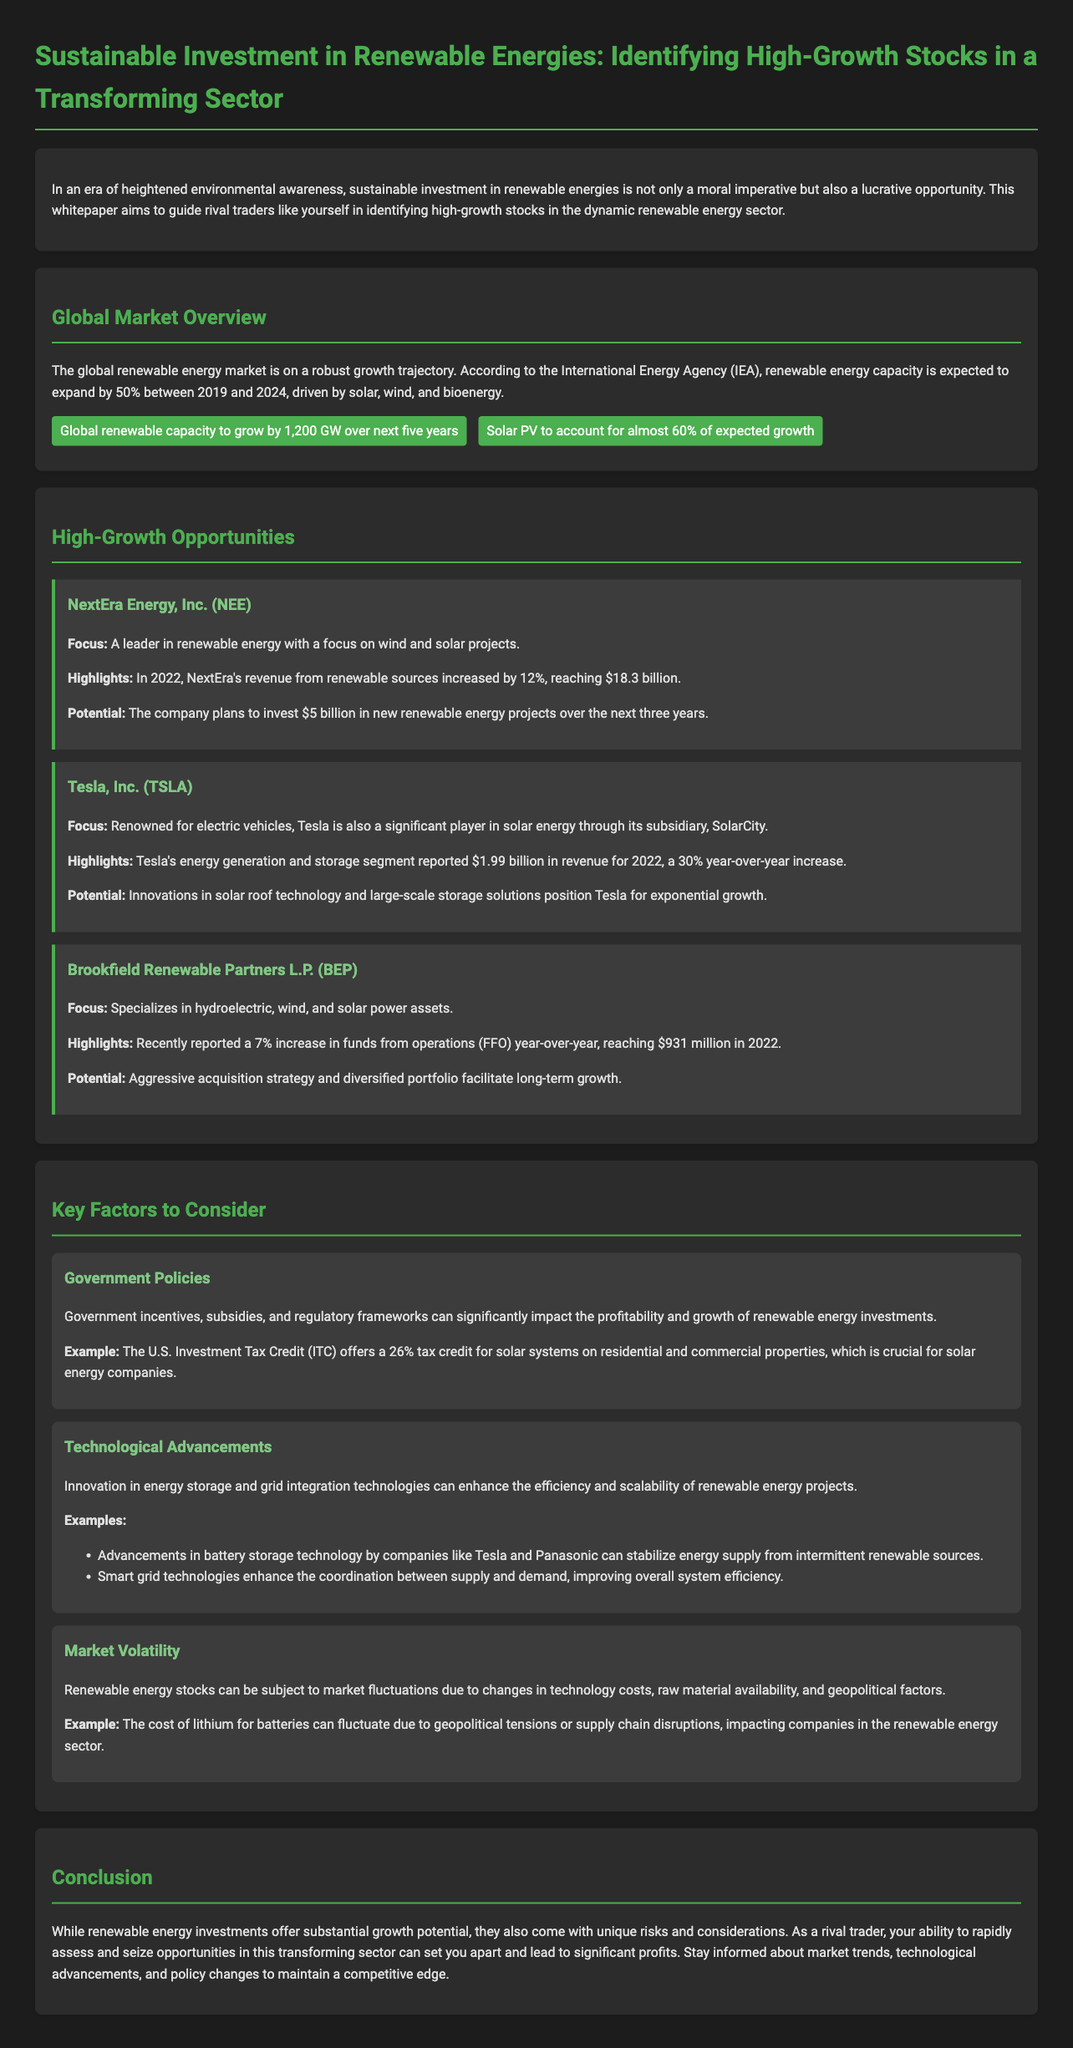what is the expected growth of global renewable capacity by 2024? The document states that global renewable capacity is expected to grow by 1,200 GW over the next five years.
Answer: 1,200 GW who is the leader in renewable energy with a focus on wind and solar projects? The document identifies NextEra Energy, Inc. as a leader in renewable energy with a focus on wind and solar projects.
Answer: NextEra Energy, Inc what percentage of expected growth does solar PV account for? According to the document, solar PV is expected to account for almost 60% of renewable capacity growth.
Answer: almost 60% what was Tesla's revenue from energy generation and storage in 2022? The document notes that Tesla's energy generation and storage segment reported $1.99 billion in revenue for 2022.
Answer: $1.99 billion which government incentive offers a 26% tax credit for solar systems? The document mentions that the U.S. Investment Tax Credit (ITC) offers a 26% tax credit for solar systems.
Answer: U.S. Investment Tax Credit (ITC) how much does NextEra plan to invest in renewable energy projects over the next three years? The document outlines that NextEra plans to invest $5 billion in new renewable energy projects over the next three years.
Answer: $5 billion what was the percentage increase in funds from operations for Brookfield Renewable Partners L.P. year-over-year? The document states that Brookfield Renewable Partners reported a 7% increase in funds from operations year-over-year.
Answer: 7% what is a significant factor affecting profitability in renewable energy investments? The document highlights government policies as a significant factor impacting the profitability of renewable energy investments.
Answer: Government policies how does technological advancement influence renewable energy projects? The document discusses that innovation in energy storage and grid integration technologies enhances efficiency and scalability.
Answer: Enhances efficiency and scalability 